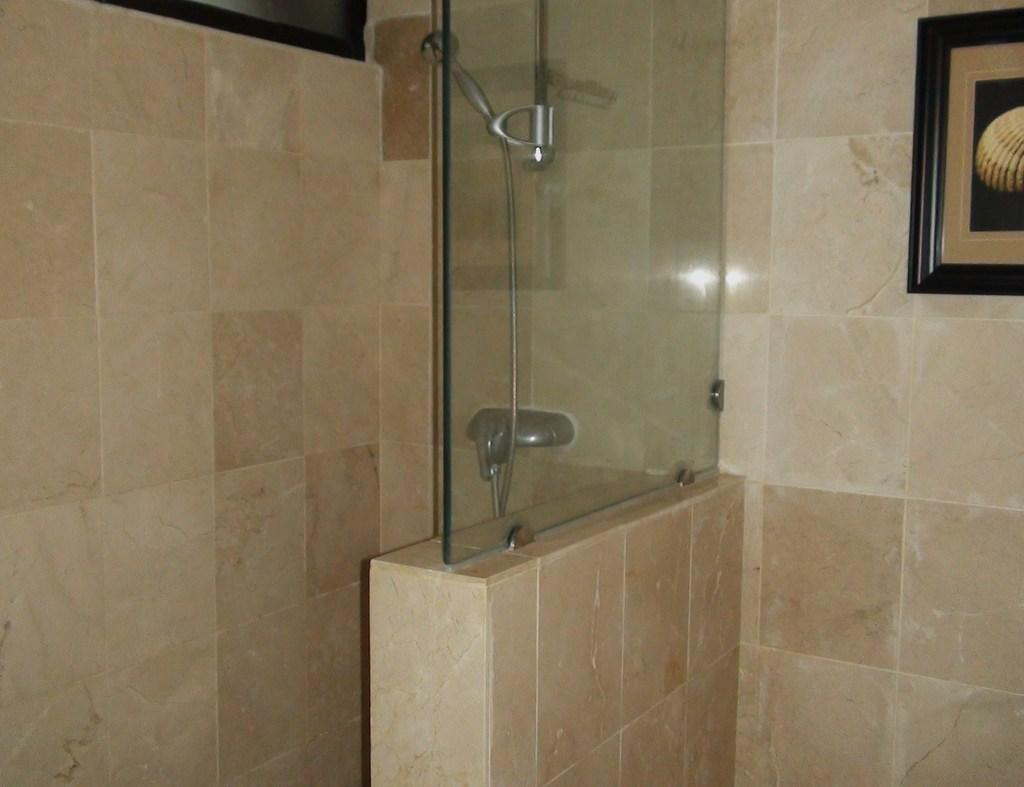What object is visible in the image that is typically used for holding liquids? There is a glass in the image. What feature is present in the image that is used for controlling the flow of water? There is a tap in the image. What type of structure can be seen in the image that provides support and separation? There is a wall in the image. What component is visible in the image that is used for transporting water or other fluids? There is a pipe in the image. What element is present in the image that serves as a border or boundary? There is a frame in the image. What type of bell can be heard ringing in the image? There is no bell present in the image, and therefore no sound can be heard. What hobbies are the people in the image engaged in? The image does not depict any people, so their hobbies cannot be determined. 